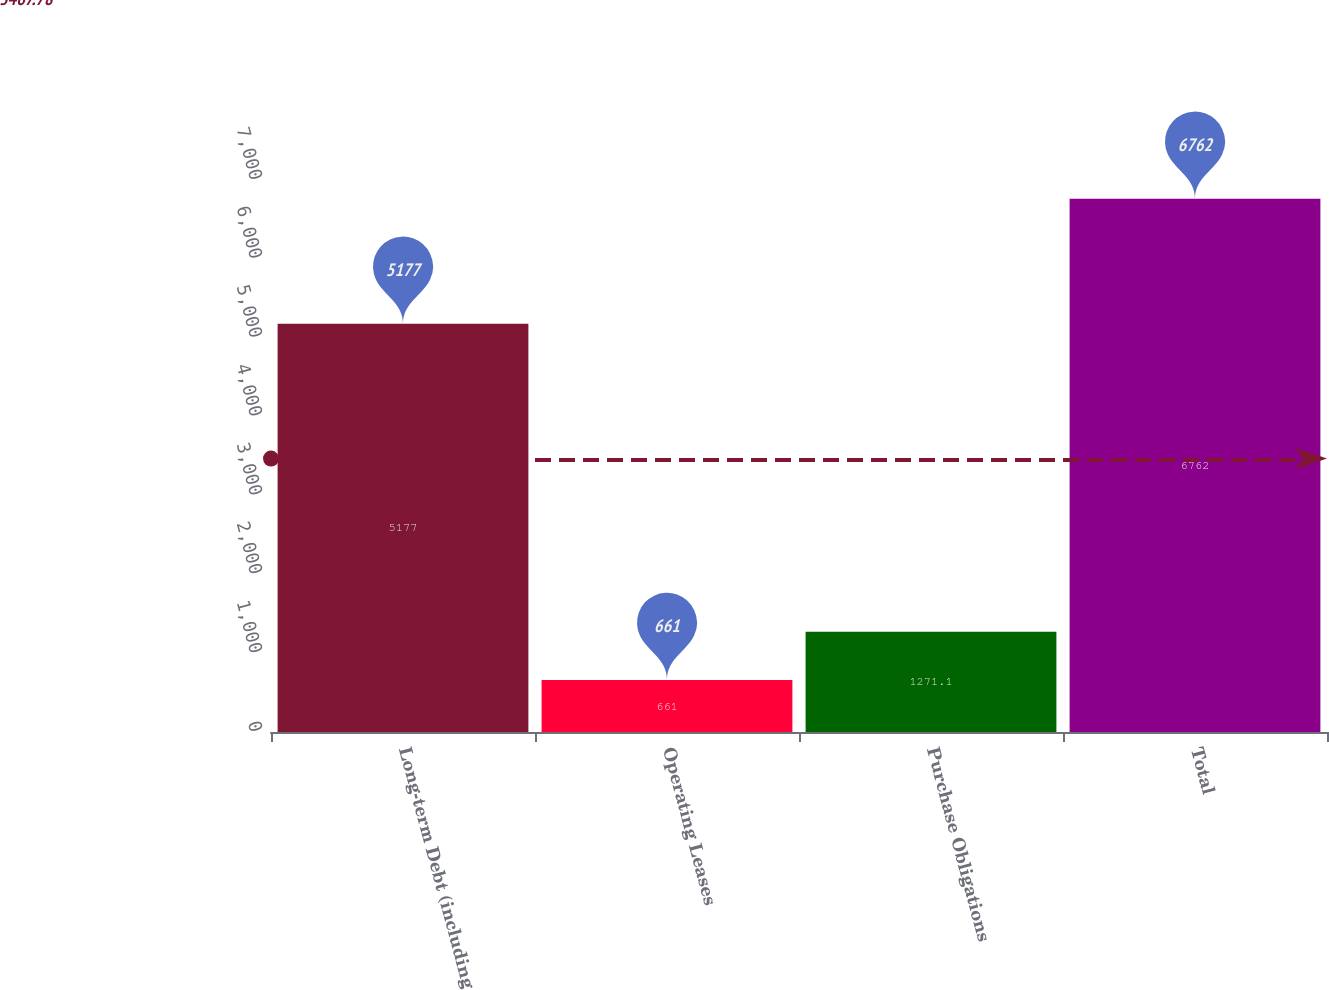<chart> <loc_0><loc_0><loc_500><loc_500><bar_chart><fcel>Long-term Debt (including<fcel>Operating Leases<fcel>Purchase Obligations<fcel>Total<nl><fcel>5177<fcel>661<fcel>1271.1<fcel>6762<nl></chart> 